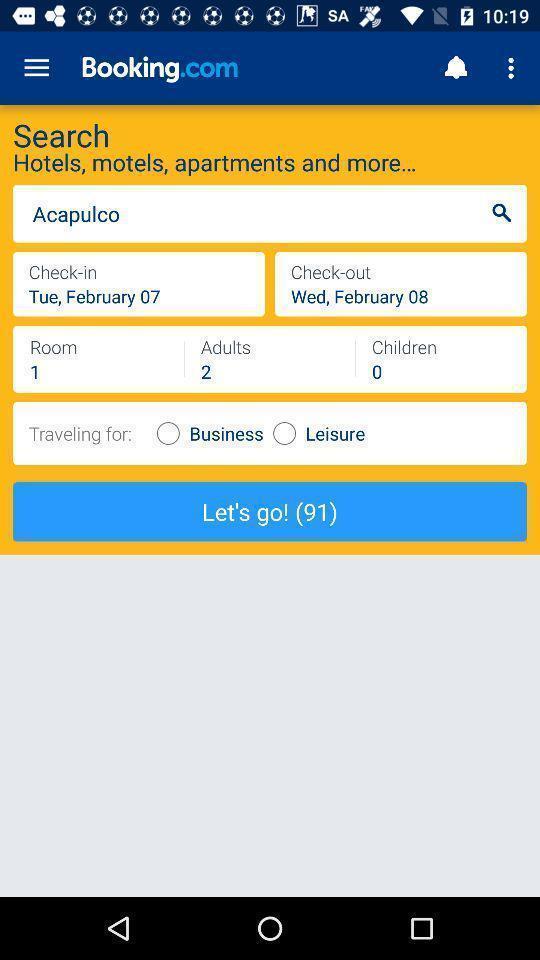Please provide a description for this image. Page shows information about an application. 